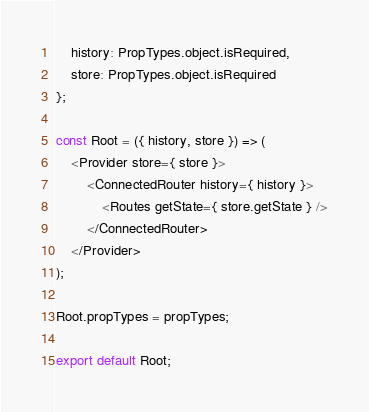Convert code to text. <code><loc_0><loc_0><loc_500><loc_500><_JavaScript_>    history: PropTypes.object.isRequired,
    store: PropTypes.object.isRequired
};

const Root = ({ history, store }) => (
    <Provider store={ store }>
        <ConnectedRouter history={ history }>
            <Routes getState={ store.getState } />
        </ConnectedRouter>
    </Provider>
);

Root.propTypes = propTypes;

export default Root;
</code> 